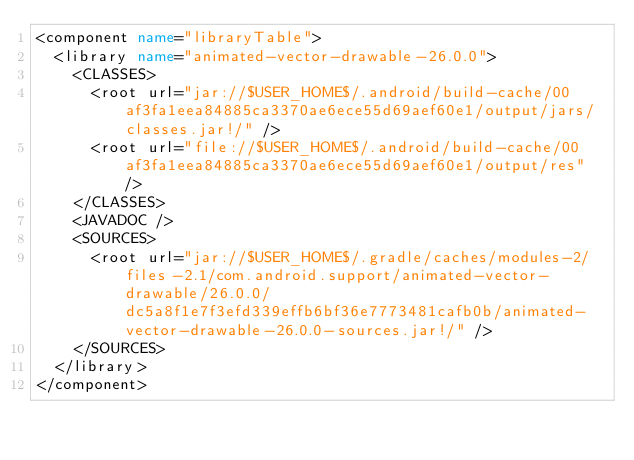Convert code to text. <code><loc_0><loc_0><loc_500><loc_500><_XML_><component name="libraryTable">
  <library name="animated-vector-drawable-26.0.0">
    <CLASSES>
      <root url="jar://$USER_HOME$/.android/build-cache/00af3fa1eea84885ca3370ae6ece55d69aef60e1/output/jars/classes.jar!/" />
      <root url="file://$USER_HOME$/.android/build-cache/00af3fa1eea84885ca3370ae6ece55d69aef60e1/output/res" />
    </CLASSES>
    <JAVADOC />
    <SOURCES>
      <root url="jar://$USER_HOME$/.gradle/caches/modules-2/files-2.1/com.android.support/animated-vector-drawable/26.0.0/dc5a8f1e7f3efd339effb6bf36e7773481cafb0b/animated-vector-drawable-26.0.0-sources.jar!/" />
    </SOURCES>
  </library>
</component></code> 